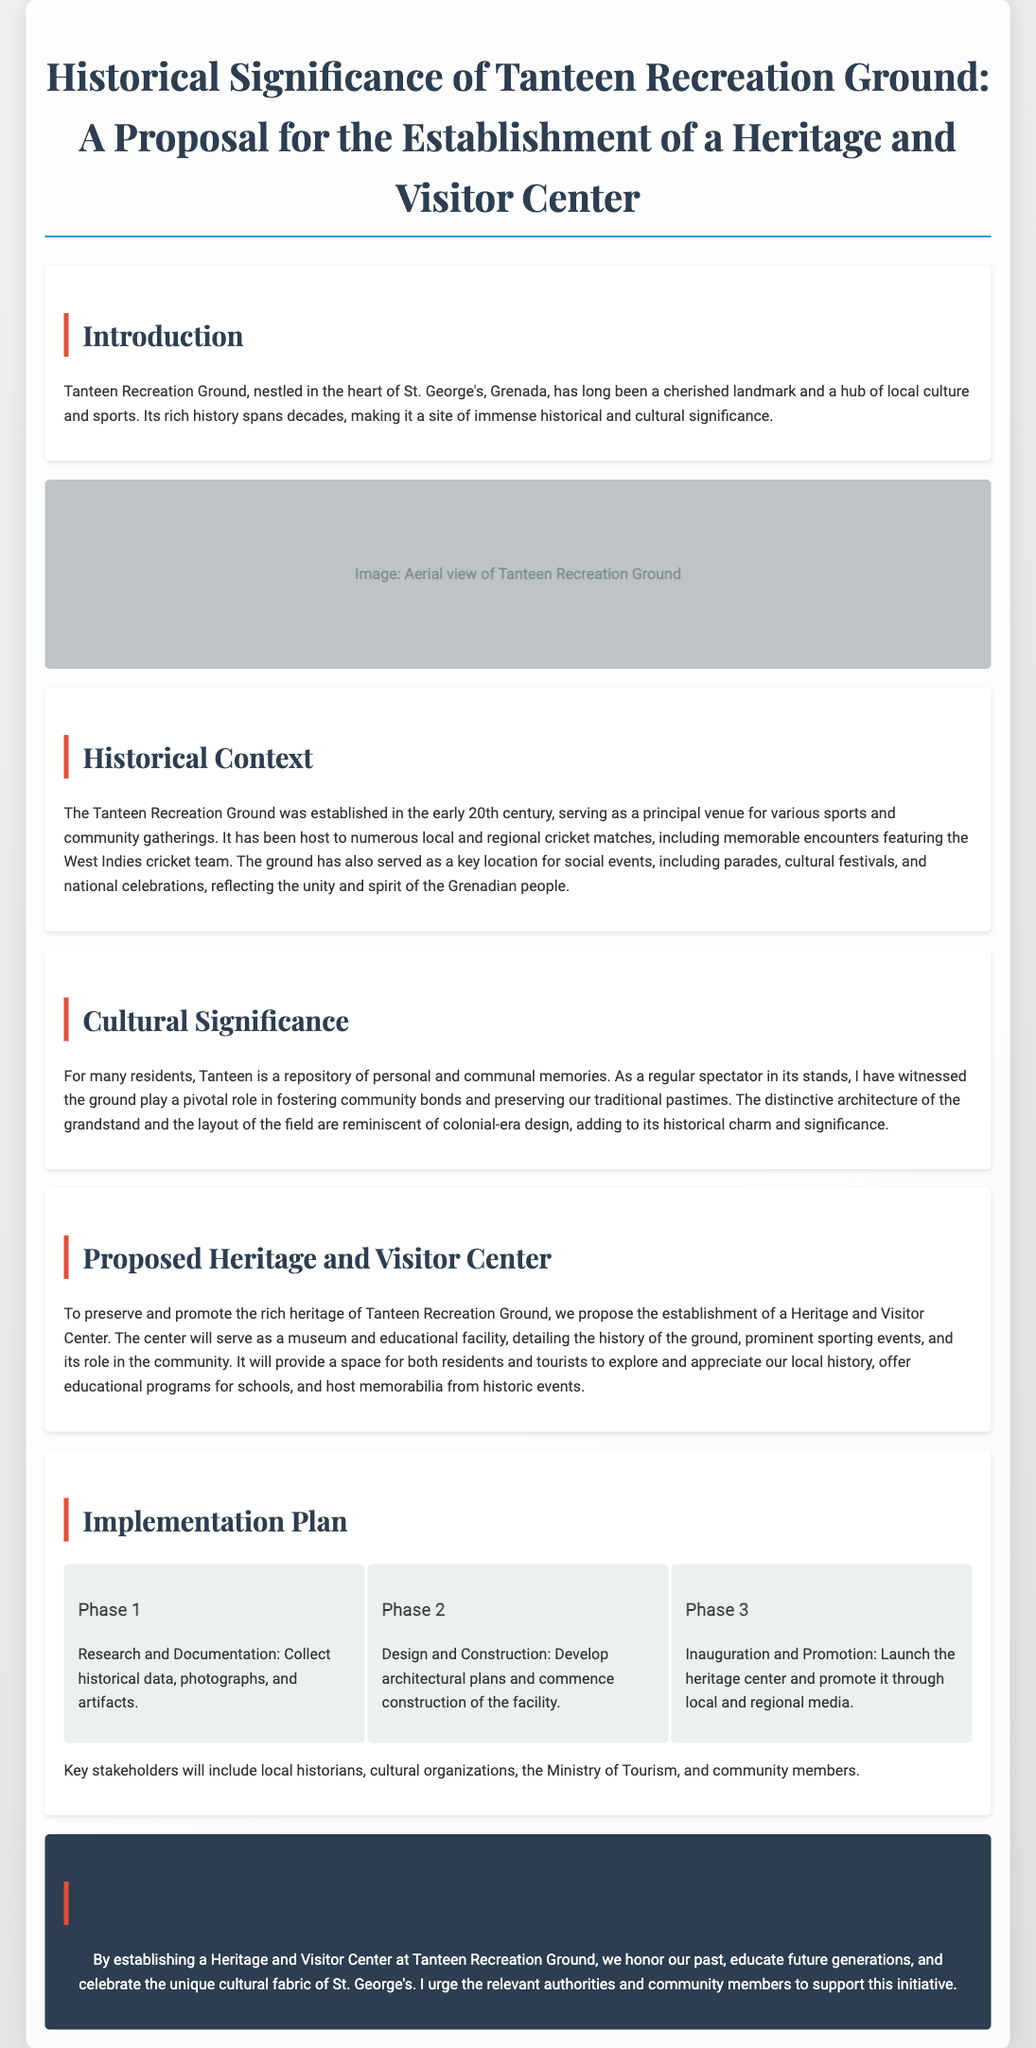what is the title of the proposal? The title of the proposal is directly stated at the beginning of the document.
Answer: Historical Significance of Tanteen Recreation Ground: A Proposal for the Establishment of a Heritage and Visitor Center when was the Tanteen Recreation Ground established? The document states that the Tanteen Recreation Ground was established in the early 20th century.
Answer: early 20th century who are the key stakeholders mentioned in the proposal? The proposal lists the key stakeholders that play a role in the establishment of the Heritage and Visitor Center.
Answer: local historians, cultural organizations, the Ministry of Tourism, and community members what is the purpose of the proposed Heritage and Visitor Center? The document outlines the main purpose of the center, which aims to educate and preserve local history.
Answer: preserve and promote the rich heritage how many phases are in the implementation plan? The proposal details the implementation plan, breaking it down into distinct phases.
Answer: three what types of events has the Tanteen Recreation Ground hosted? The document references the types of events that have taken place at the Tanteen Recreation Ground.
Answer: cricket matches, parades, cultural festivals, national celebrations what will the Heritage and Visitor Center serve as? The proposal describes the function of the Heritage and Visitor Center in promoting local history.
Answer: a museum and educational facility what architectural style is mentioned in relation to the grandstand? The document references a specific style associated with the grandstand's architecture.
Answer: colonial-era design 